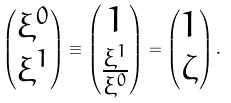<formula> <loc_0><loc_0><loc_500><loc_500>\begin{pmatrix} \xi ^ { 0 } \\ \xi ^ { 1 } \\ \end{pmatrix} \equiv \begin{pmatrix} 1 \\ \frac { \xi ^ { 1 } } { \xi ^ { 0 } } \\ \end{pmatrix} = \begin{pmatrix} 1 \\ \zeta \\ \end{pmatrix} .</formula> 